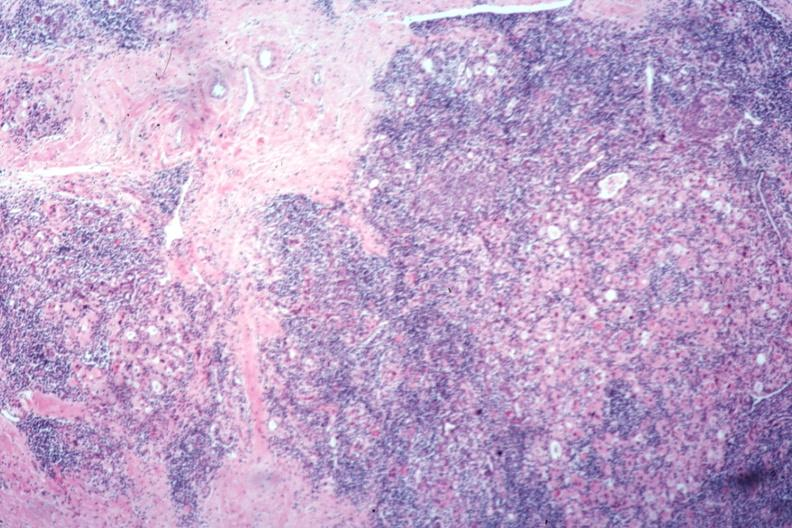s aorta present?
Answer the question using a single word or phrase. No 